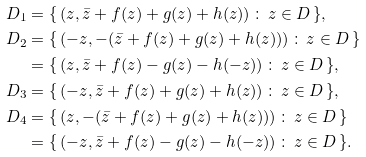Convert formula to latex. <formula><loc_0><loc_0><loc_500><loc_500>D _ { 1 } & = \{ \, ( z , \bar { z } + f ( z ) + g ( z ) + h ( z ) ) \, \colon \, z \in D \, \} , \\ D _ { 2 } & = \{ \, ( - z , - ( \bar { z } + f ( z ) + g ( z ) + h ( z ) ) ) \, \colon \, z \in D \, \} \\ & = \{ \, ( z , \bar { z } + f ( z ) - g ( z ) - h ( - z ) ) \, \colon \, z \in D \, \} , \\ D _ { 3 } & = \{ \, ( - z , \bar { z } + f ( z ) + g ( z ) + h ( z ) ) \, \colon \, z \in D \, \} , \\ D _ { 4 } & = \{ \, ( z , - ( \bar { z } + f ( z ) + g ( z ) + h ( z ) ) ) \, \colon \, z \in D \, \} \\ & = \{ \, ( - z , \bar { z } + f ( z ) - g ( z ) - h ( - z ) ) \, \colon \, z \in D \, \} .</formula> 